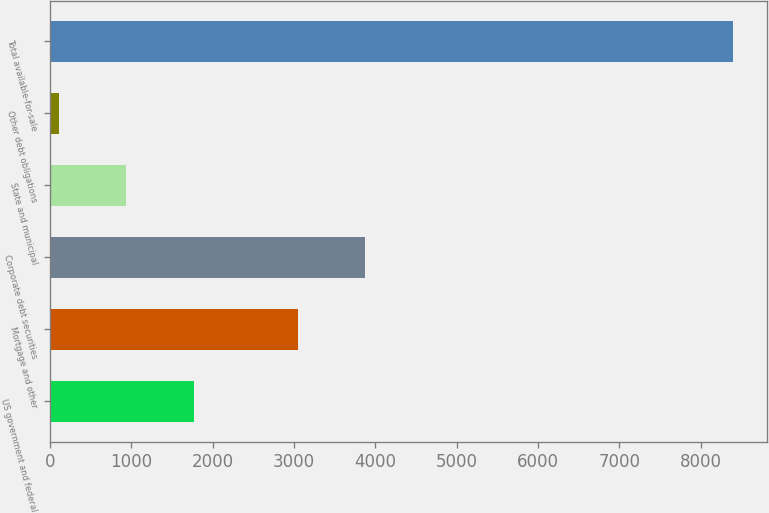Convert chart. <chart><loc_0><loc_0><loc_500><loc_500><bar_chart><fcel>US government and federal<fcel>Mortgage and other<fcel>Corporate debt securities<fcel>State and municipal<fcel>Other debt obligations<fcel>Total available-for-sale<nl><fcel>1768<fcel>3049<fcel>3877<fcel>940<fcel>112<fcel>8392<nl></chart> 